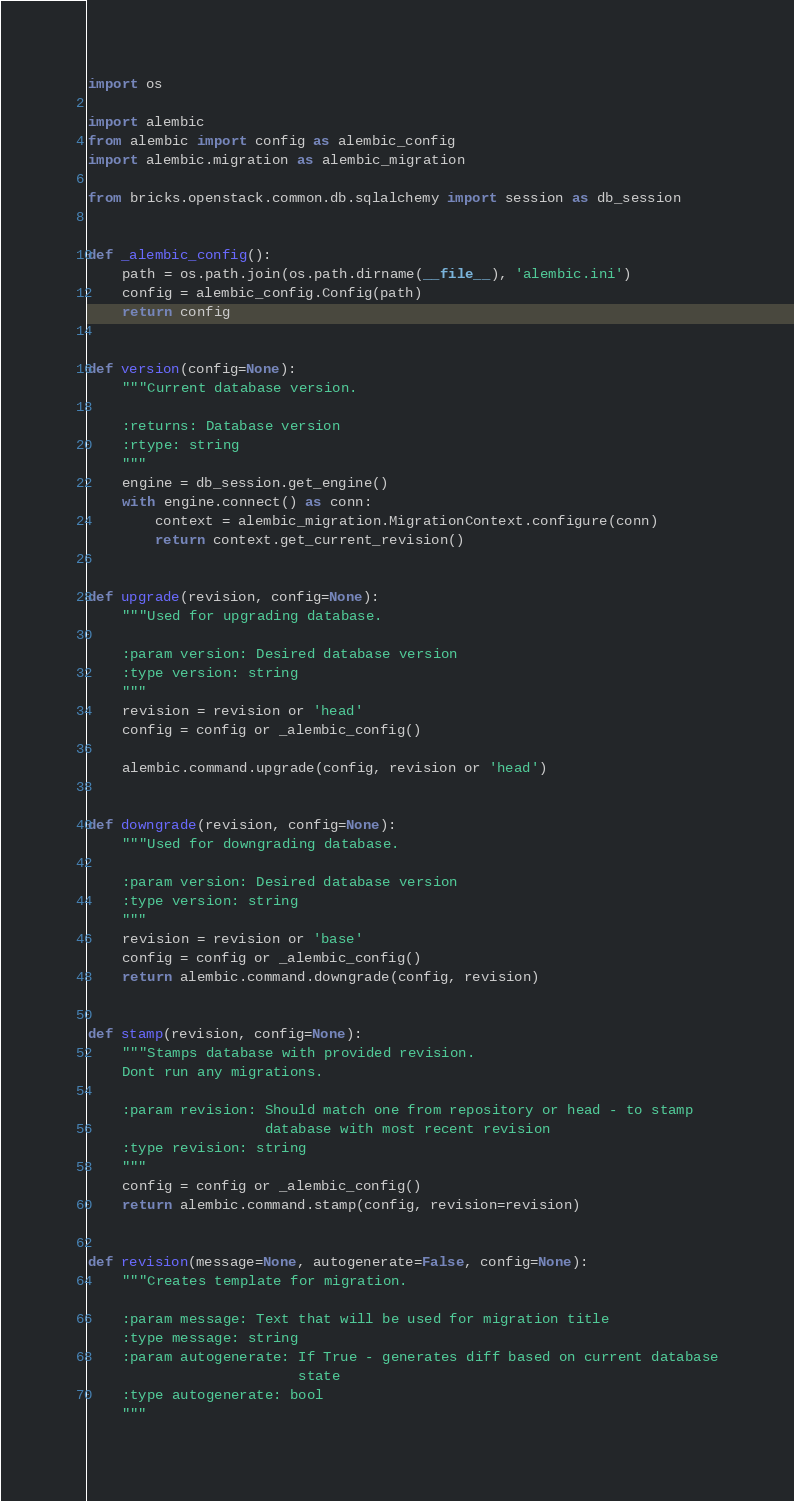<code> <loc_0><loc_0><loc_500><loc_500><_Python_>import os

import alembic
from alembic import config as alembic_config
import alembic.migration as alembic_migration

from bricks.openstack.common.db.sqlalchemy import session as db_session


def _alembic_config():
    path = os.path.join(os.path.dirname(__file__), 'alembic.ini')
    config = alembic_config.Config(path)
    return config


def version(config=None):
    """Current database version.

    :returns: Database version
    :rtype: string
    """
    engine = db_session.get_engine()
    with engine.connect() as conn:
        context = alembic_migration.MigrationContext.configure(conn)
        return context.get_current_revision()


def upgrade(revision, config=None):
    """Used for upgrading database.

    :param version: Desired database version
    :type version: string
    """
    revision = revision or 'head'
    config = config or _alembic_config()

    alembic.command.upgrade(config, revision or 'head')


def downgrade(revision, config=None):
    """Used for downgrading database.

    :param version: Desired database version
    :type version: string
    """
    revision = revision or 'base'
    config = config or _alembic_config()
    return alembic.command.downgrade(config, revision)


def stamp(revision, config=None):
    """Stamps database with provided revision.
    Dont run any migrations.

    :param revision: Should match one from repository or head - to stamp
                     database with most recent revision
    :type revision: string
    """
    config = config or _alembic_config()
    return alembic.command.stamp(config, revision=revision)


def revision(message=None, autogenerate=False, config=None):
    """Creates template for migration.

    :param message: Text that will be used for migration title
    :type message: string
    :param autogenerate: If True - generates diff based on current database
                         state
    :type autogenerate: bool
    """</code> 